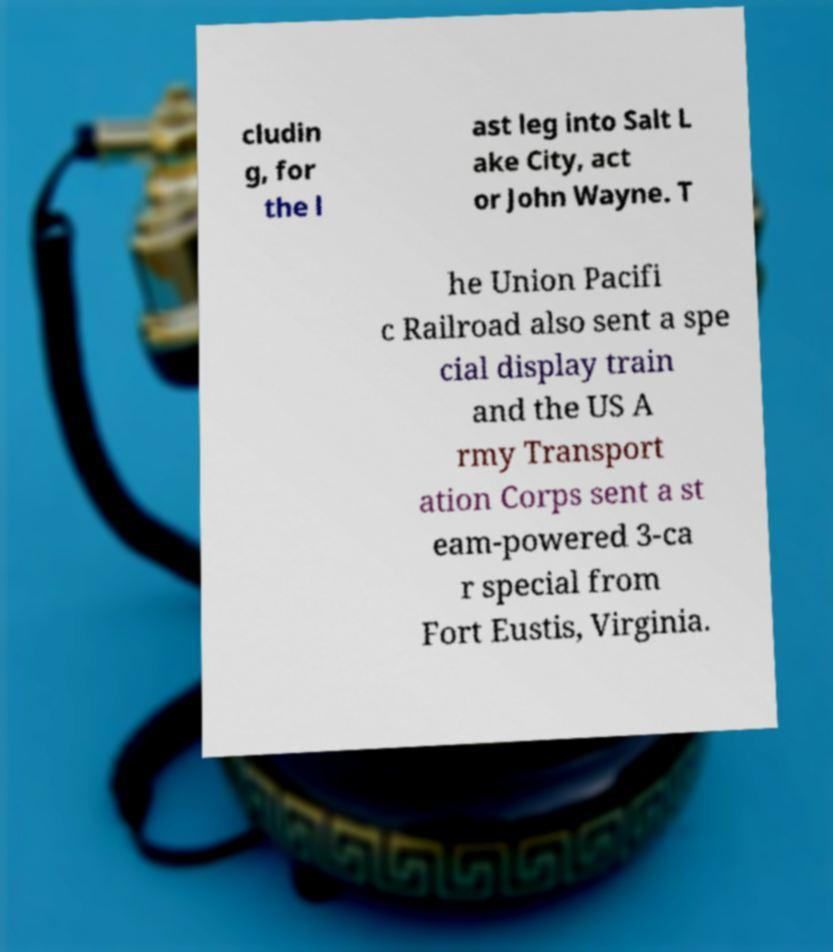There's text embedded in this image that I need extracted. Can you transcribe it verbatim? cludin g, for the l ast leg into Salt L ake City, act or John Wayne. T he Union Pacifi c Railroad also sent a spe cial display train and the US A rmy Transport ation Corps sent a st eam-powered 3-ca r special from Fort Eustis, Virginia. 